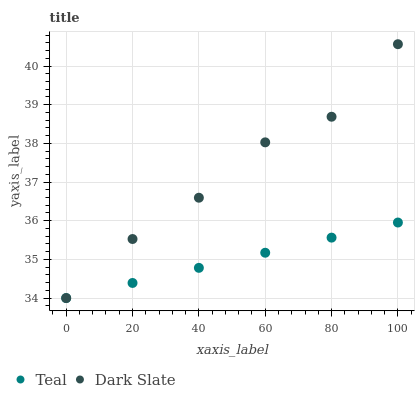Does Teal have the minimum area under the curve?
Answer yes or no. Yes. Does Dark Slate have the maximum area under the curve?
Answer yes or no. Yes. Does Teal have the maximum area under the curve?
Answer yes or no. No. Is Teal the smoothest?
Answer yes or no. Yes. Is Dark Slate the roughest?
Answer yes or no. Yes. Is Teal the roughest?
Answer yes or no. No. Does Dark Slate have the lowest value?
Answer yes or no. Yes. Does Dark Slate have the highest value?
Answer yes or no. Yes. Does Teal have the highest value?
Answer yes or no. No. Does Teal intersect Dark Slate?
Answer yes or no. Yes. Is Teal less than Dark Slate?
Answer yes or no. No. Is Teal greater than Dark Slate?
Answer yes or no. No. 